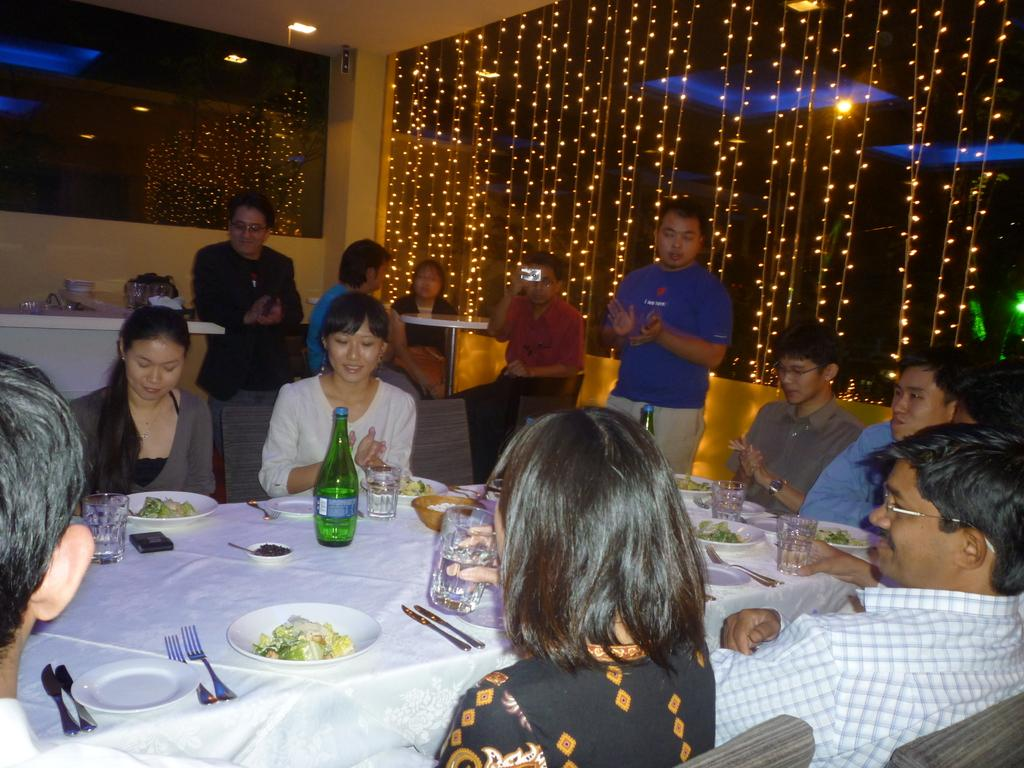What are the people in the image doing? There is a group of people sitting in chairs in the image. What is in front of the group of people? There is a table in front of the group of people. What can be found on the table? The table has eatables and drinks on it. Are there any other people visible in the image? Yes, there are people in the background of the image. What type of roof can be seen in the image? There is no roof visible in the image. Can you describe the fog in the image? There is no fog present in the image. 